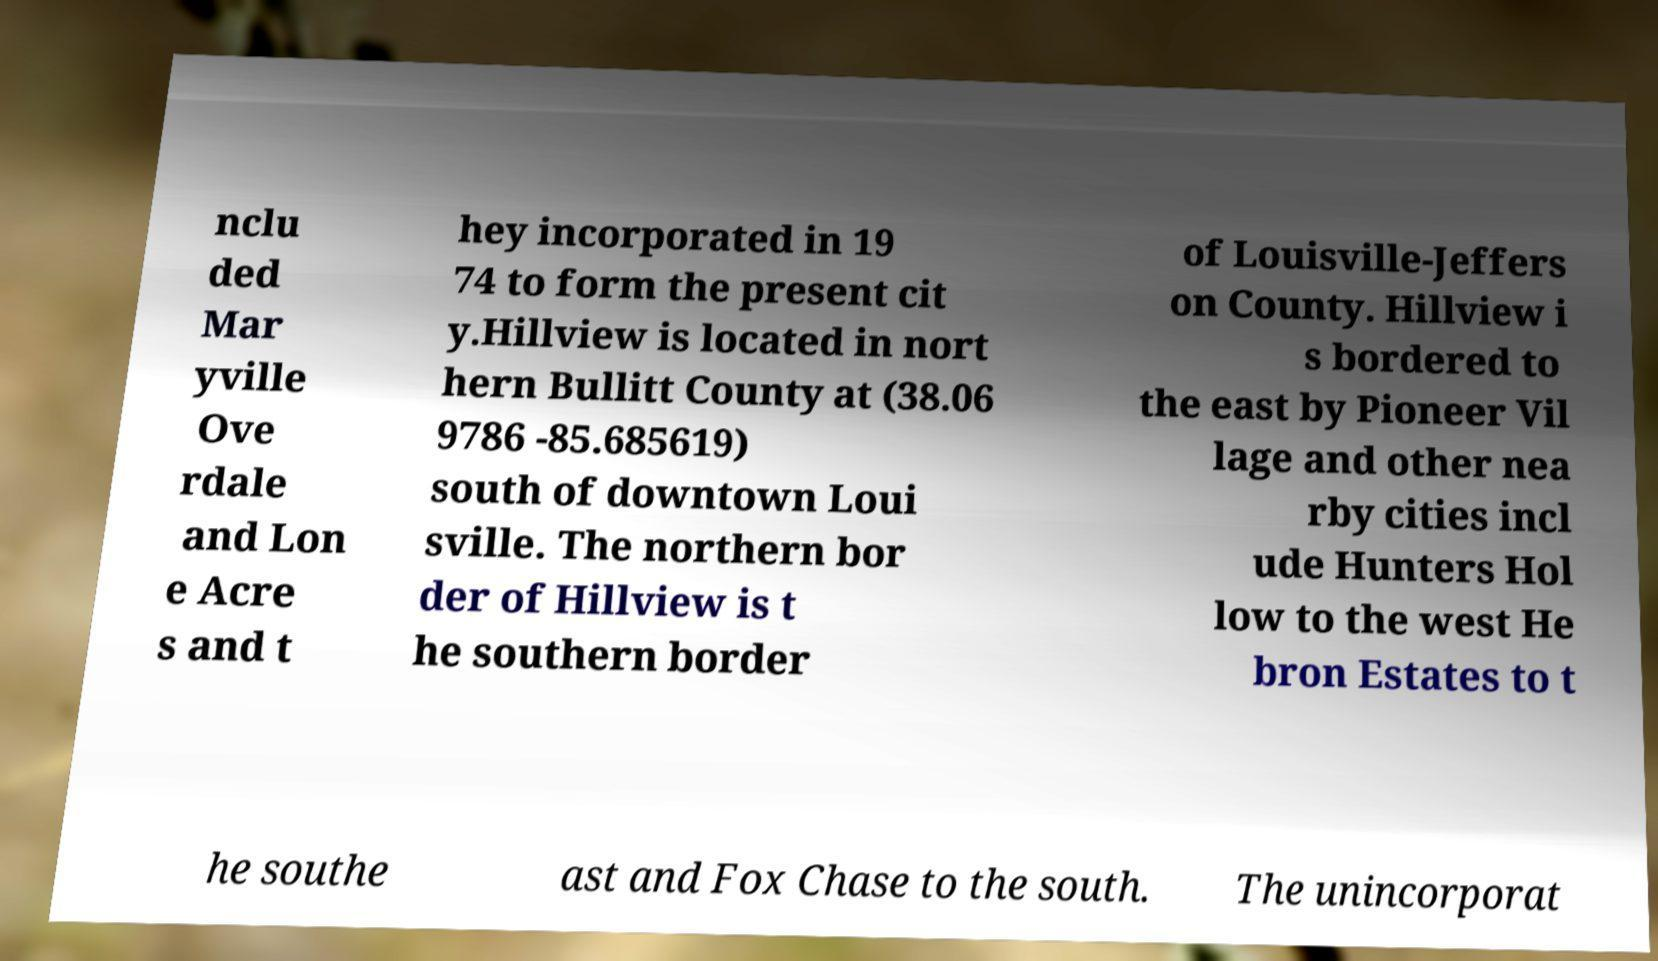What messages or text are displayed in this image? I need them in a readable, typed format. nclu ded Mar yville Ove rdale and Lon e Acre s and t hey incorporated in 19 74 to form the present cit y.Hillview is located in nort hern Bullitt County at (38.06 9786 -85.685619) south of downtown Loui sville. The northern bor der of Hillview is t he southern border of Louisville-Jeffers on County. Hillview i s bordered to the east by Pioneer Vil lage and other nea rby cities incl ude Hunters Hol low to the west He bron Estates to t he southe ast and Fox Chase to the south. The unincorporat 